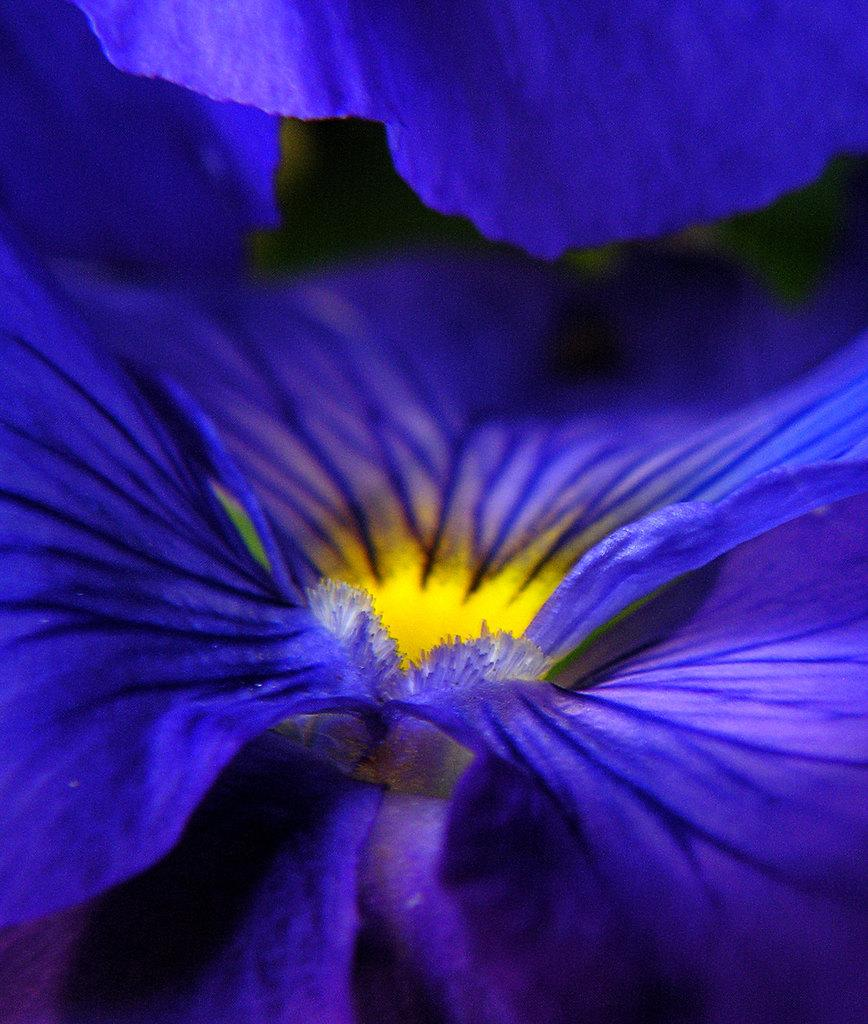What type of flower is present in the image? There is a blue color flower in the image. What color is the background of the image? The background of the image is black. How many children are playing with the son in the image? There is no reference to children or a son in the image; it only features a blue color flower and a black background. 